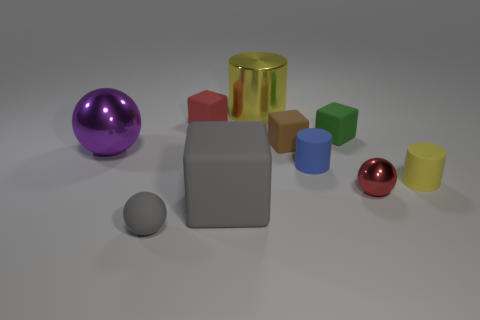What number of metallic things have the same size as the blue matte cylinder?
Your answer should be very brief. 1. How many yellow objects are balls or tiny spheres?
Provide a short and direct response. 0. Are there the same number of red blocks that are in front of the blue object and small gray cylinders?
Make the answer very short. Yes. There is a block in front of the tiny yellow rubber thing; how big is it?
Keep it short and to the point. Large. How many small green matte things have the same shape as the big gray matte thing?
Make the answer very short. 1. There is a large object that is both behind the small shiny ball and in front of the small brown object; what material is it?
Offer a terse response. Metal. Do the big yellow object and the small green block have the same material?
Make the answer very short. No. What number of gray things are there?
Your answer should be compact. 2. There is a ball that is in front of the tiny red object to the right of the big shiny object behind the small green rubber object; what color is it?
Your answer should be very brief. Gray. Do the big matte object and the matte sphere have the same color?
Offer a very short reply. Yes. 